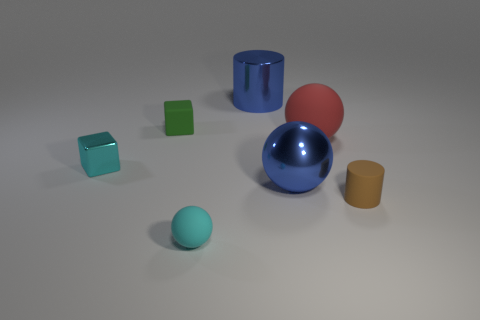Subtract all green blocks. How many blocks are left? 1 Subtract all red balls. How many balls are left? 2 Subtract all balls. How many objects are left? 4 Subtract all cyan cubes. How many blue balls are left? 1 Add 4 rubber things. How many rubber things are left? 8 Add 5 rubber cubes. How many rubber cubes exist? 6 Add 1 tiny cylinders. How many objects exist? 8 Subtract 0 blue cubes. How many objects are left? 7 Subtract 2 cubes. How many cubes are left? 0 Subtract all cyan cubes. Subtract all red cylinders. How many cubes are left? 1 